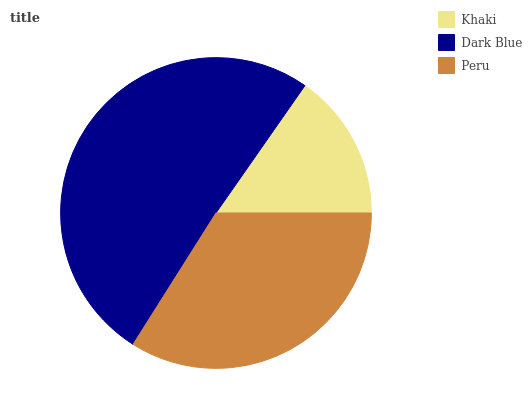Is Khaki the minimum?
Answer yes or no. Yes. Is Dark Blue the maximum?
Answer yes or no. Yes. Is Peru the minimum?
Answer yes or no. No. Is Peru the maximum?
Answer yes or no. No. Is Dark Blue greater than Peru?
Answer yes or no. Yes. Is Peru less than Dark Blue?
Answer yes or no. Yes. Is Peru greater than Dark Blue?
Answer yes or no. No. Is Dark Blue less than Peru?
Answer yes or no. No. Is Peru the high median?
Answer yes or no. Yes. Is Peru the low median?
Answer yes or no. Yes. Is Khaki the high median?
Answer yes or no. No. Is Dark Blue the low median?
Answer yes or no. No. 